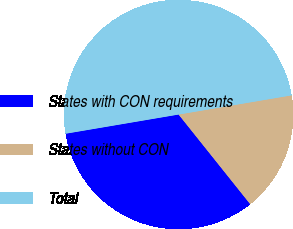Convert chart to OTSL. <chart><loc_0><loc_0><loc_500><loc_500><pie_chart><fcel>States with CON requirements<fcel>States without CON<fcel>Total<nl><fcel>33.05%<fcel>16.95%<fcel>50.0%<nl></chart> 